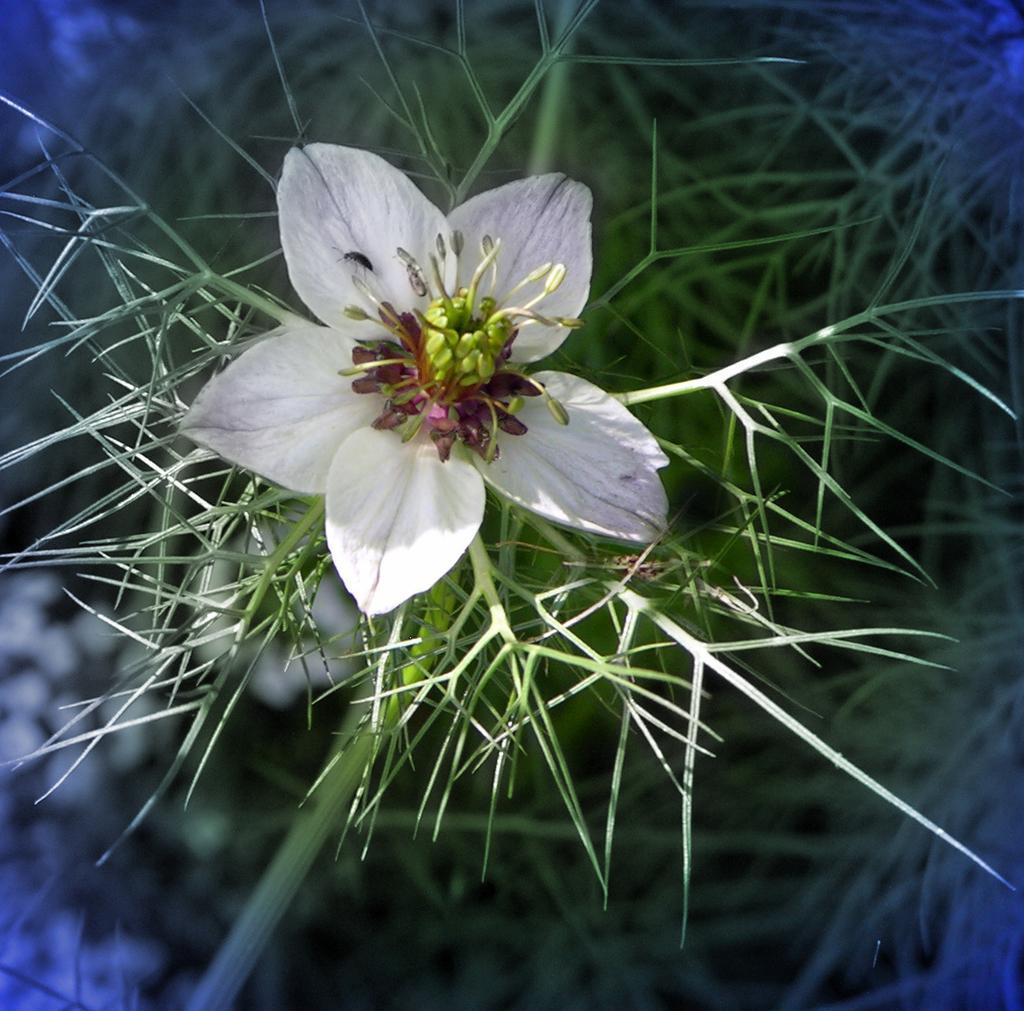Describe this image in one or two sentences. In the foreground of this image, there is a flower of a plant. 